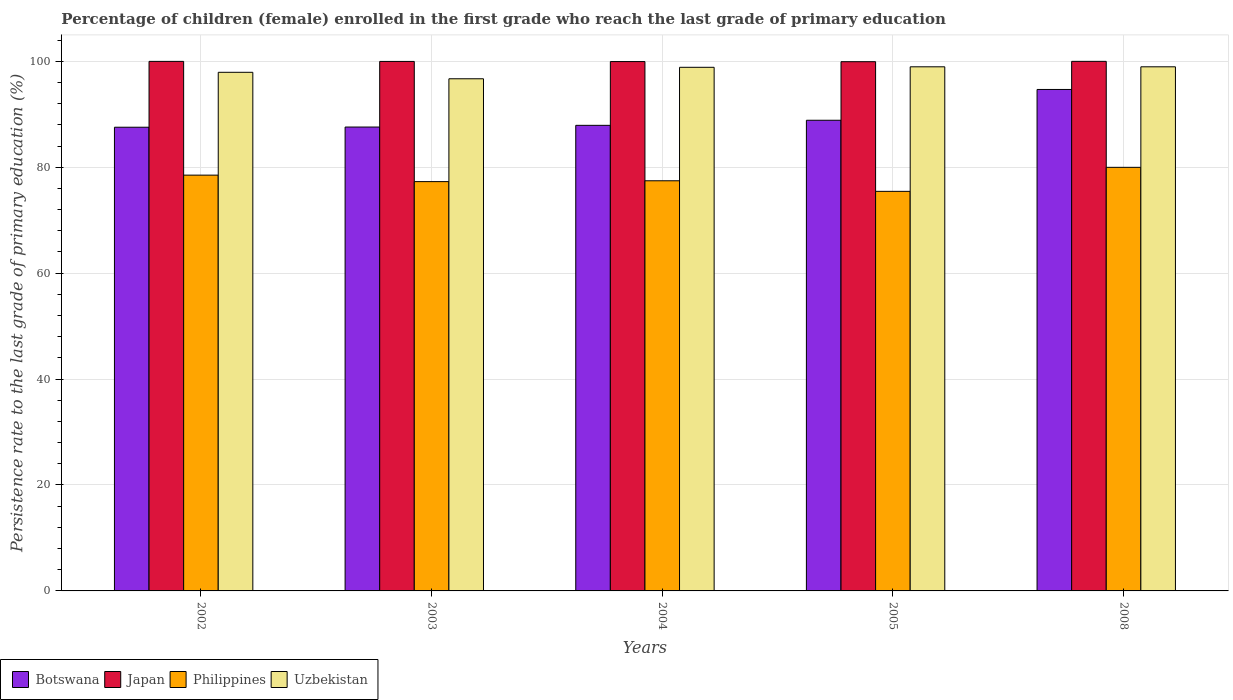Are the number of bars on each tick of the X-axis equal?
Give a very brief answer. Yes. In how many cases, is the number of bars for a given year not equal to the number of legend labels?
Your response must be concise. 0. What is the persistence rate of children in Botswana in 2002?
Provide a short and direct response. 87.55. Across all years, what is the maximum persistence rate of children in Uzbekistan?
Ensure brevity in your answer.  98.96. Across all years, what is the minimum persistence rate of children in Uzbekistan?
Make the answer very short. 96.69. In which year was the persistence rate of children in Philippines minimum?
Give a very brief answer. 2005. What is the total persistence rate of children in Philippines in the graph?
Make the answer very short. 388.63. What is the difference between the persistence rate of children in Botswana in 2002 and that in 2005?
Offer a terse response. -1.32. What is the difference between the persistence rate of children in Uzbekistan in 2008 and the persistence rate of children in Japan in 2003?
Your answer should be compact. -1.01. What is the average persistence rate of children in Japan per year?
Your answer should be compact. 99.96. In the year 2004, what is the difference between the persistence rate of children in Japan and persistence rate of children in Philippines?
Ensure brevity in your answer.  22.51. What is the ratio of the persistence rate of children in Botswana in 2003 to that in 2005?
Your answer should be compact. 0.99. Is the difference between the persistence rate of children in Japan in 2002 and 2003 greater than the difference between the persistence rate of children in Philippines in 2002 and 2003?
Give a very brief answer. No. What is the difference between the highest and the second highest persistence rate of children in Botswana?
Give a very brief answer. 5.81. What is the difference between the highest and the lowest persistence rate of children in Botswana?
Offer a very short reply. 7.13. Is the sum of the persistence rate of children in Philippines in 2002 and 2004 greater than the maximum persistence rate of children in Uzbekistan across all years?
Your response must be concise. Yes. Is it the case that in every year, the sum of the persistence rate of children in Philippines and persistence rate of children in Japan is greater than the sum of persistence rate of children in Botswana and persistence rate of children in Uzbekistan?
Offer a terse response. Yes. What does the 1st bar from the left in 2008 represents?
Keep it short and to the point. Botswana. How many bars are there?
Your answer should be compact. 20. Are all the bars in the graph horizontal?
Ensure brevity in your answer.  No. What is the difference between two consecutive major ticks on the Y-axis?
Give a very brief answer. 20. Where does the legend appear in the graph?
Make the answer very short. Bottom left. What is the title of the graph?
Ensure brevity in your answer.  Percentage of children (female) enrolled in the first grade who reach the last grade of primary education. Does "Philippines" appear as one of the legend labels in the graph?
Your answer should be very brief. Yes. What is the label or title of the X-axis?
Offer a very short reply. Years. What is the label or title of the Y-axis?
Make the answer very short. Persistence rate to the last grade of primary education (%). What is the Persistence rate to the last grade of primary education (%) in Botswana in 2002?
Provide a short and direct response. 87.55. What is the Persistence rate to the last grade of primary education (%) of Japan in 2002?
Give a very brief answer. 99.98. What is the Persistence rate to the last grade of primary education (%) in Philippines in 2002?
Offer a terse response. 78.5. What is the Persistence rate to the last grade of primary education (%) of Uzbekistan in 2002?
Keep it short and to the point. 97.92. What is the Persistence rate to the last grade of primary education (%) of Botswana in 2003?
Provide a succinct answer. 87.58. What is the Persistence rate to the last grade of primary education (%) in Japan in 2003?
Make the answer very short. 99.97. What is the Persistence rate to the last grade of primary education (%) of Philippines in 2003?
Offer a terse response. 77.28. What is the Persistence rate to the last grade of primary education (%) in Uzbekistan in 2003?
Provide a succinct answer. 96.69. What is the Persistence rate to the last grade of primary education (%) of Botswana in 2004?
Provide a succinct answer. 87.9. What is the Persistence rate to the last grade of primary education (%) of Japan in 2004?
Provide a short and direct response. 99.94. What is the Persistence rate to the last grade of primary education (%) of Philippines in 2004?
Offer a very short reply. 77.44. What is the Persistence rate to the last grade of primary education (%) of Uzbekistan in 2004?
Your response must be concise. 98.86. What is the Persistence rate to the last grade of primary education (%) of Botswana in 2005?
Give a very brief answer. 88.86. What is the Persistence rate to the last grade of primary education (%) in Japan in 2005?
Your answer should be very brief. 99.92. What is the Persistence rate to the last grade of primary education (%) of Philippines in 2005?
Provide a short and direct response. 75.44. What is the Persistence rate to the last grade of primary education (%) in Uzbekistan in 2005?
Provide a succinct answer. 98.95. What is the Persistence rate to the last grade of primary education (%) of Botswana in 2008?
Make the answer very short. 94.68. What is the Persistence rate to the last grade of primary education (%) in Japan in 2008?
Your answer should be very brief. 99.98. What is the Persistence rate to the last grade of primary education (%) of Philippines in 2008?
Your response must be concise. 79.98. What is the Persistence rate to the last grade of primary education (%) of Uzbekistan in 2008?
Your answer should be compact. 98.96. Across all years, what is the maximum Persistence rate to the last grade of primary education (%) of Botswana?
Offer a terse response. 94.68. Across all years, what is the maximum Persistence rate to the last grade of primary education (%) of Japan?
Offer a terse response. 99.98. Across all years, what is the maximum Persistence rate to the last grade of primary education (%) in Philippines?
Provide a short and direct response. 79.98. Across all years, what is the maximum Persistence rate to the last grade of primary education (%) of Uzbekistan?
Give a very brief answer. 98.96. Across all years, what is the minimum Persistence rate to the last grade of primary education (%) in Botswana?
Provide a succinct answer. 87.55. Across all years, what is the minimum Persistence rate to the last grade of primary education (%) of Japan?
Provide a succinct answer. 99.92. Across all years, what is the minimum Persistence rate to the last grade of primary education (%) in Philippines?
Make the answer very short. 75.44. Across all years, what is the minimum Persistence rate to the last grade of primary education (%) in Uzbekistan?
Offer a terse response. 96.69. What is the total Persistence rate to the last grade of primary education (%) of Botswana in the graph?
Your response must be concise. 446.57. What is the total Persistence rate to the last grade of primary education (%) in Japan in the graph?
Your answer should be compact. 499.8. What is the total Persistence rate to the last grade of primary education (%) of Philippines in the graph?
Your answer should be compact. 388.63. What is the total Persistence rate to the last grade of primary education (%) of Uzbekistan in the graph?
Make the answer very short. 491.38. What is the difference between the Persistence rate to the last grade of primary education (%) of Botswana in 2002 and that in 2003?
Provide a succinct answer. -0.03. What is the difference between the Persistence rate to the last grade of primary education (%) of Japan in 2002 and that in 2003?
Provide a succinct answer. 0.01. What is the difference between the Persistence rate to the last grade of primary education (%) in Philippines in 2002 and that in 2003?
Provide a short and direct response. 1.23. What is the difference between the Persistence rate to the last grade of primary education (%) of Uzbekistan in 2002 and that in 2003?
Your answer should be very brief. 1.22. What is the difference between the Persistence rate to the last grade of primary education (%) in Botswana in 2002 and that in 2004?
Your answer should be compact. -0.36. What is the difference between the Persistence rate to the last grade of primary education (%) of Japan in 2002 and that in 2004?
Your answer should be very brief. 0.04. What is the difference between the Persistence rate to the last grade of primary education (%) in Philippines in 2002 and that in 2004?
Your answer should be compact. 1.07. What is the difference between the Persistence rate to the last grade of primary education (%) of Uzbekistan in 2002 and that in 2004?
Keep it short and to the point. -0.94. What is the difference between the Persistence rate to the last grade of primary education (%) of Botswana in 2002 and that in 2005?
Your answer should be very brief. -1.32. What is the difference between the Persistence rate to the last grade of primary education (%) of Japan in 2002 and that in 2005?
Your answer should be very brief. 0.06. What is the difference between the Persistence rate to the last grade of primary education (%) in Philippines in 2002 and that in 2005?
Your response must be concise. 3.06. What is the difference between the Persistence rate to the last grade of primary education (%) in Uzbekistan in 2002 and that in 2005?
Give a very brief answer. -1.04. What is the difference between the Persistence rate to the last grade of primary education (%) in Botswana in 2002 and that in 2008?
Your answer should be very brief. -7.13. What is the difference between the Persistence rate to the last grade of primary education (%) of Japan in 2002 and that in 2008?
Your response must be concise. -0. What is the difference between the Persistence rate to the last grade of primary education (%) of Philippines in 2002 and that in 2008?
Give a very brief answer. -1.47. What is the difference between the Persistence rate to the last grade of primary education (%) in Uzbekistan in 2002 and that in 2008?
Offer a very short reply. -1.04. What is the difference between the Persistence rate to the last grade of primary education (%) in Botswana in 2003 and that in 2004?
Give a very brief answer. -0.32. What is the difference between the Persistence rate to the last grade of primary education (%) of Japan in 2003 and that in 2004?
Ensure brevity in your answer.  0.03. What is the difference between the Persistence rate to the last grade of primary education (%) in Philippines in 2003 and that in 2004?
Provide a succinct answer. -0.16. What is the difference between the Persistence rate to the last grade of primary education (%) in Uzbekistan in 2003 and that in 2004?
Your answer should be very brief. -2.17. What is the difference between the Persistence rate to the last grade of primary education (%) in Botswana in 2003 and that in 2005?
Give a very brief answer. -1.28. What is the difference between the Persistence rate to the last grade of primary education (%) of Japan in 2003 and that in 2005?
Ensure brevity in your answer.  0.05. What is the difference between the Persistence rate to the last grade of primary education (%) of Philippines in 2003 and that in 2005?
Provide a succinct answer. 1.84. What is the difference between the Persistence rate to the last grade of primary education (%) of Uzbekistan in 2003 and that in 2005?
Provide a succinct answer. -2.26. What is the difference between the Persistence rate to the last grade of primary education (%) of Botswana in 2003 and that in 2008?
Offer a terse response. -7.1. What is the difference between the Persistence rate to the last grade of primary education (%) of Japan in 2003 and that in 2008?
Ensure brevity in your answer.  -0.01. What is the difference between the Persistence rate to the last grade of primary education (%) in Philippines in 2003 and that in 2008?
Provide a short and direct response. -2.7. What is the difference between the Persistence rate to the last grade of primary education (%) in Uzbekistan in 2003 and that in 2008?
Your answer should be very brief. -2.26. What is the difference between the Persistence rate to the last grade of primary education (%) of Botswana in 2004 and that in 2005?
Your answer should be very brief. -0.96. What is the difference between the Persistence rate to the last grade of primary education (%) in Japan in 2004 and that in 2005?
Make the answer very short. 0.02. What is the difference between the Persistence rate to the last grade of primary education (%) in Philippines in 2004 and that in 2005?
Your response must be concise. 2. What is the difference between the Persistence rate to the last grade of primary education (%) of Uzbekistan in 2004 and that in 2005?
Provide a short and direct response. -0.09. What is the difference between the Persistence rate to the last grade of primary education (%) of Botswana in 2004 and that in 2008?
Your answer should be very brief. -6.77. What is the difference between the Persistence rate to the last grade of primary education (%) of Japan in 2004 and that in 2008?
Keep it short and to the point. -0.04. What is the difference between the Persistence rate to the last grade of primary education (%) of Philippines in 2004 and that in 2008?
Offer a terse response. -2.54. What is the difference between the Persistence rate to the last grade of primary education (%) in Uzbekistan in 2004 and that in 2008?
Give a very brief answer. -0.1. What is the difference between the Persistence rate to the last grade of primary education (%) in Botswana in 2005 and that in 2008?
Make the answer very short. -5.81. What is the difference between the Persistence rate to the last grade of primary education (%) in Japan in 2005 and that in 2008?
Your answer should be very brief. -0.06. What is the difference between the Persistence rate to the last grade of primary education (%) of Philippines in 2005 and that in 2008?
Offer a terse response. -4.54. What is the difference between the Persistence rate to the last grade of primary education (%) in Uzbekistan in 2005 and that in 2008?
Provide a short and direct response. -0. What is the difference between the Persistence rate to the last grade of primary education (%) in Botswana in 2002 and the Persistence rate to the last grade of primary education (%) in Japan in 2003?
Provide a succinct answer. -12.42. What is the difference between the Persistence rate to the last grade of primary education (%) of Botswana in 2002 and the Persistence rate to the last grade of primary education (%) of Philippines in 2003?
Give a very brief answer. 10.27. What is the difference between the Persistence rate to the last grade of primary education (%) in Botswana in 2002 and the Persistence rate to the last grade of primary education (%) in Uzbekistan in 2003?
Ensure brevity in your answer.  -9.15. What is the difference between the Persistence rate to the last grade of primary education (%) of Japan in 2002 and the Persistence rate to the last grade of primary education (%) of Philippines in 2003?
Ensure brevity in your answer.  22.7. What is the difference between the Persistence rate to the last grade of primary education (%) in Japan in 2002 and the Persistence rate to the last grade of primary education (%) in Uzbekistan in 2003?
Your response must be concise. 3.29. What is the difference between the Persistence rate to the last grade of primary education (%) of Philippines in 2002 and the Persistence rate to the last grade of primary education (%) of Uzbekistan in 2003?
Offer a terse response. -18.19. What is the difference between the Persistence rate to the last grade of primary education (%) in Botswana in 2002 and the Persistence rate to the last grade of primary education (%) in Japan in 2004?
Ensure brevity in your answer.  -12.39. What is the difference between the Persistence rate to the last grade of primary education (%) of Botswana in 2002 and the Persistence rate to the last grade of primary education (%) of Philippines in 2004?
Provide a short and direct response. 10.11. What is the difference between the Persistence rate to the last grade of primary education (%) of Botswana in 2002 and the Persistence rate to the last grade of primary education (%) of Uzbekistan in 2004?
Your response must be concise. -11.31. What is the difference between the Persistence rate to the last grade of primary education (%) in Japan in 2002 and the Persistence rate to the last grade of primary education (%) in Philippines in 2004?
Your answer should be compact. 22.54. What is the difference between the Persistence rate to the last grade of primary education (%) in Japan in 2002 and the Persistence rate to the last grade of primary education (%) in Uzbekistan in 2004?
Provide a succinct answer. 1.12. What is the difference between the Persistence rate to the last grade of primary education (%) of Philippines in 2002 and the Persistence rate to the last grade of primary education (%) of Uzbekistan in 2004?
Offer a very short reply. -20.36. What is the difference between the Persistence rate to the last grade of primary education (%) in Botswana in 2002 and the Persistence rate to the last grade of primary education (%) in Japan in 2005?
Give a very brief answer. -12.37. What is the difference between the Persistence rate to the last grade of primary education (%) in Botswana in 2002 and the Persistence rate to the last grade of primary education (%) in Philippines in 2005?
Ensure brevity in your answer.  12.11. What is the difference between the Persistence rate to the last grade of primary education (%) in Botswana in 2002 and the Persistence rate to the last grade of primary education (%) in Uzbekistan in 2005?
Your response must be concise. -11.41. What is the difference between the Persistence rate to the last grade of primary education (%) of Japan in 2002 and the Persistence rate to the last grade of primary education (%) of Philippines in 2005?
Your response must be concise. 24.54. What is the difference between the Persistence rate to the last grade of primary education (%) of Japan in 2002 and the Persistence rate to the last grade of primary education (%) of Uzbekistan in 2005?
Provide a succinct answer. 1.03. What is the difference between the Persistence rate to the last grade of primary education (%) of Philippines in 2002 and the Persistence rate to the last grade of primary education (%) of Uzbekistan in 2005?
Keep it short and to the point. -20.45. What is the difference between the Persistence rate to the last grade of primary education (%) of Botswana in 2002 and the Persistence rate to the last grade of primary education (%) of Japan in 2008?
Make the answer very short. -12.44. What is the difference between the Persistence rate to the last grade of primary education (%) in Botswana in 2002 and the Persistence rate to the last grade of primary education (%) in Philippines in 2008?
Give a very brief answer. 7.57. What is the difference between the Persistence rate to the last grade of primary education (%) in Botswana in 2002 and the Persistence rate to the last grade of primary education (%) in Uzbekistan in 2008?
Provide a short and direct response. -11.41. What is the difference between the Persistence rate to the last grade of primary education (%) in Japan in 2002 and the Persistence rate to the last grade of primary education (%) in Philippines in 2008?
Your answer should be very brief. 20. What is the difference between the Persistence rate to the last grade of primary education (%) of Japan in 2002 and the Persistence rate to the last grade of primary education (%) of Uzbekistan in 2008?
Offer a terse response. 1.02. What is the difference between the Persistence rate to the last grade of primary education (%) of Philippines in 2002 and the Persistence rate to the last grade of primary education (%) of Uzbekistan in 2008?
Provide a succinct answer. -20.45. What is the difference between the Persistence rate to the last grade of primary education (%) in Botswana in 2003 and the Persistence rate to the last grade of primary education (%) in Japan in 2004?
Your answer should be very brief. -12.36. What is the difference between the Persistence rate to the last grade of primary education (%) of Botswana in 2003 and the Persistence rate to the last grade of primary education (%) of Philippines in 2004?
Make the answer very short. 10.15. What is the difference between the Persistence rate to the last grade of primary education (%) in Botswana in 2003 and the Persistence rate to the last grade of primary education (%) in Uzbekistan in 2004?
Your answer should be compact. -11.28. What is the difference between the Persistence rate to the last grade of primary education (%) in Japan in 2003 and the Persistence rate to the last grade of primary education (%) in Philippines in 2004?
Provide a succinct answer. 22.53. What is the difference between the Persistence rate to the last grade of primary education (%) in Japan in 2003 and the Persistence rate to the last grade of primary education (%) in Uzbekistan in 2004?
Make the answer very short. 1.11. What is the difference between the Persistence rate to the last grade of primary education (%) in Philippines in 2003 and the Persistence rate to the last grade of primary education (%) in Uzbekistan in 2004?
Offer a very short reply. -21.58. What is the difference between the Persistence rate to the last grade of primary education (%) of Botswana in 2003 and the Persistence rate to the last grade of primary education (%) of Japan in 2005?
Your answer should be very brief. -12.34. What is the difference between the Persistence rate to the last grade of primary education (%) of Botswana in 2003 and the Persistence rate to the last grade of primary education (%) of Philippines in 2005?
Your answer should be compact. 12.14. What is the difference between the Persistence rate to the last grade of primary education (%) in Botswana in 2003 and the Persistence rate to the last grade of primary education (%) in Uzbekistan in 2005?
Your response must be concise. -11.37. What is the difference between the Persistence rate to the last grade of primary education (%) of Japan in 2003 and the Persistence rate to the last grade of primary education (%) of Philippines in 2005?
Keep it short and to the point. 24.53. What is the difference between the Persistence rate to the last grade of primary education (%) in Japan in 2003 and the Persistence rate to the last grade of primary education (%) in Uzbekistan in 2005?
Provide a short and direct response. 1.02. What is the difference between the Persistence rate to the last grade of primary education (%) in Philippines in 2003 and the Persistence rate to the last grade of primary education (%) in Uzbekistan in 2005?
Offer a terse response. -21.68. What is the difference between the Persistence rate to the last grade of primary education (%) of Botswana in 2003 and the Persistence rate to the last grade of primary education (%) of Japan in 2008?
Keep it short and to the point. -12.4. What is the difference between the Persistence rate to the last grade of primary education (%) in Botswana in 2003 and the Persistence rate to the last grade of primary education (%) in Philippines in 2008?
Keep it short and to the point. 7.61. What is the difference between the Persistence rate to the last grade of primary education (%) of Botswana in 2003 and the Persistence rate to the last grade of primary education (%) of Uzbekistan in 2008?
Your answer should be compact. -11.37. What is the difference between the Persistence rate to the last grade of primary education (%) in Japan in 2003 and the Persistence rate to the last grade of primary education (%) in Philippines in 2008?
Keep it short and to the point. 19.99. What is the difference between the Persistence rate to the last grade of primary education (%) of Japan in 2003 and the Persistence rate to the last grade of primary education (%) of Uzbekistan in 2008?
Provide a succinct answer. 1.01. What is the difference between the Persistence rate to the last grade of primary education (%) in Philippines in 2003 and the Persistence rate to the last grade of primary education (%) in Uzbekistan in 2008?
Your response must be concise. -21.68. What is the difference between the Persistence rate to the last grade of primary education (%) of Botswana in 2004 and the Persistence rate to the last grade of primary education (%) of Japan in 2005?
Keep it short and to the point. -12.02. What is the difference between the Persistence rate to the last grade of primary education (%) in Botswana in 2004 and the Persistence rate to the last grade of primary education (%) in Philippines in 2005?
Your answer should be very brief. 12.46. What is the difference between the Persistence rate to the last grade of primary education (%) in Botswana in 2004 and the Persistence rate to the last grade of primary education (%) in Uzbekistan in 2005?
Your answer should be compact. -11.05. What is the difference between the Persistence rate to the last grade of primary education (%) of Japan in 2004 and the Persistence rate to the last grade of primary education (%) of Philippines in 2005?
Ensure brevity in your answer.  24.5. What is the difference between the Persistence rate to the last grade of primary education (%) of Philippines in 2004 and the Persistence rate to the last grade of primary education (%) of Uzbekistan in 2005?
Your answer should be compact. -21.52. What is the difference between the Persistence rate to the last grade of primary education (%) of Botswana in 2004 and the Persistence rate to the last grade of primary education (%) of Japan in 2008?
Your answer should be compact. -12.08. What is the difference between the Persistence rate to the last grade of primary education (%) of Botswana in 2004 and the Persistence rate to the last grade of primary education (%) of Philippines in 2008?
Your response must be concise. 7.93. What is the difference between the Persistence rate to the last grade of primary education (%) in Botswana in 2004 and the Persistence rate to the last grade of primary education (%) in Uzbekistan in 2008?
Make the answer very short. -11.05. What is the difference between the Persistence rate to the last grade of primary education (%) in Japan in 2004 and the Persistence rate to the last grade of primary education (%) in Philippines in 2008?
Offer a very short reply. 19.97. What is the difference between the Persistence rate to the last grade of primary education (%) of Japan in 2004 and the Persistence rate to the last grade of primary education (%) of Uzbekistan in 2008?
Give a very brief answer. 0.99. What is the difference between the Persistence rate to the last grade of primary education (%) of Philippines in 2004 and the Persistence rate to the last grade of primary education (%) of Uzbekistan in 2008?
Your answer should be compact. -21.52. What is the difference between the Persistence rate to the last grade of primary education (%) in Botswana in 2005 and the Persistence rate to the last grade of primary education (%) in Japan in 2008?
Make the answer very short. -11.12. What is the difference between the Persistence rate to the last grade of primary education (%) in Botswana in 2005 and the Persistence rate to the last grade of primary education (%) in Philippines in 2008?
Your response must be concise. 8.89. What is the difference between the Persistence rate to the last grade of primary education (%) in Botswana in 2005 and the Persistence rate to the last grade of primary education (%) in Uzbekistan in 2008?
Keep it short and to the point. -10.09. What is the difference between the Persistence rate to the last grade of primary education (%) in Japan in 2005 and the Persistence rate to the last grade of primary education (%) in Philippines in 2008?
Keep it short and to the point. 19.94. What is the difference between the Persistence rate to the last grade of primary education (%) in Japan in 2005 and the Persistence rate to the last grade of primary education (%) in Uzbekistan in 2008?
Ensure brevity in your answer.  0.96. What is the difference between the Persistence rate to the last grade of primary education (%) in Philippines in 2005 and the Persistence rate to the last grade of primary education (%) in Uzbekistan in 2008?
Give a very brief answer. -23.52. What is the average Persistence rate to the last grade of primary education (%) in Botswana per year?
Ensure brevity in your answer.  89.31. What is the average Persistence rate to the last grade of primary education (%) in Japan per year?
Give a very brief answer. 99.96. What is the average Persistence rate to the last grade of primary education (%) of Philippines per year?
Offer a very short reply. 77.73. What is the average Persistence rate to the last grade of primary education (%) of Uzbekistan per year?
Provide a succinct answer. 98.28. In the year 2002, what is the difference between the Persistence rate to the last grade of primary education (%) of Botswana and Persistence rate to the last grade of primary education (%) of Japan?
Give a very brief answer. -12.43. In the year 2002, what is the difference between the Persistence rate to the last grade of primary education (%) of Botswana and Persistence rate to the last grade of primary education (%) of Philippines?
Your response must be concise. 9.05. In the year 2002, what is the difference between the Persistence rate to the last grade of primary education (%) of Botswana and Persistence rate to the last grade of primary education (%) of Uzbekistan?
Provide a succinct answer. -10.37. In the year 2002, what is the difference between the Persistence rate to the last grade of primary education (%) of Japan and Persistence rate to the last grade of primary education (%) of Philippines?
Your response must be concise. 21.48. In the year 2002, what is the difference between the Persistence rate to the last grade of primary education (%) in Japan and Persistence rate to the last grade of primary education (%) in Uzbekistan?
Provide a succinct answer. 2.06. In the year 2002, what is the difference between the Persistence rate to the last grade of primary education (%) of Philippines and Persistence rate to the last grade of primary education (%) of Uzbekistan?
Keep it short and to the point. -19.41. In the year 2003, what is the difference between the Persistence rate to the last grade of primary education (%) of Botswana and Persistence rate to the last grade of primary education (%) of Japan?
Your answer should be very brief. -12.39. In the year 2003, what is the difference between the Persistence rate to the last grade of primary education (%) in Botswana and Persistence rate to the last grade of primary education (%) in Philippines?
Make the answer very short. 10.3. In the year 2003, what is the difference between the Persistence rate to the last grade of primary education (%) of Botswana and Persistence rate to the last grade of primary education (%) of Uzbekistan?
Give a very brief answer. -9.11. In the year 2003, what is the difference between the Persistence rate to the last grade of primary education (%) of Japan and Persistence rate to the last grade of primary education (%) of Philippines?
Your answer should be very brief. 22.69. In the year 2003, what is the difference between the Persistence rate to the last grade of primary education (%) of Japan and Persistence rate to the last grade of primary education (%) of Uzbekistan?
Offer a terse response. 3.27. In the year 2003, what is the difference between the Persistence rate to the last grade of primary education (%) of Philippines and Persistence rate to the last grade of primary education (%) of Uzbekistan?
Offer a terse response. -19.42. In the year 2004, what is the difference between the Persistence rate to the last grade of primary education (%) of Botswana and Persistence rate to the last grade of primary education (%) of Japan?
Provide a succinct answer. -12.04. In the year 2004, what is the difference between the Persistence rate to the last grade of primary education (%) of Botswana and Persistence rate to the last grade of primary education (%) of Philippines?
Your response must be concise. 10.47. In the year 2004, what is the difference between the Persistence rate to the last grade of primary education (%) in Botswana and Persistence rate to the last grade of primary education (%) in Uzbekistan?
Your answer should be compact. -10.96. In the year 2004, what is the difference between the Persistence rate to the last grade of primary education (%) in Japan and Persistence rate to the last grade of primary education (%) in Philippines?
Offer a terse response. 22.51. In the year 2004, what is the difference between the Persistence rate to the last grade of primary education (%) of Japan and Persistence rate to the last grade of primary education (%) of Uzbekistan?
Your answer should be very brief. 1.08. In the year 2004, what is the difference between the Persistence rate to the last grade of primary education (%) of Philippines and Persistence rate to the last grade of primary education (%) of Uzbekistan?
Ensure brevity in your answer.  -21.42. In the year 2005, what is the difference between the Persistence rate to the last grade of primary education (%) in Botswana and Persistence rate to the last grade of primary education (%) in Japan?
Offer a very short reply. -11.06. In the year 2005, what is the difference between the Persistence rate to the last grade of primary education (%) in Botswana and Persistence rate to the last grade of primary education (%) in Philippines?
Your answer should be very brief. 13.42. In the year 2005, what is the difference between the Persistence rate to the last grade of primary education (%) in Botswana and Persistence rate to the last grade of primary education (%) in Uzbekistan?
Provide a short and direct response. -10.09. In the year 2005, what is the difference between the Persistence rate to the last grade of primary education (%) of Japan and Persistence rate to the last grade of primary education (%) of Philippines?
Keep it short and to the point. 24.48. In the year 2005, what is the difference between the Persistence rate to the last grade of primary education (%) in Japan and Persistence rate to the last grade of primary education (%) in Uzbekistan?
Provide a succinct answer. 0.97. In the year 2005, what is the difference between the Persistence rate to the last grade of primary education (%) of Philippines and Persistence rate to the last grade of primary education (%) of Uzbekistan?
Make the answer very short. -23.51. In the year 2008, what is the difference between the Persistence rate to the last grade of primary education (%) of Botswana and Persistence rate to the last grade of primary education (%) of Japan?
Provide a short and direct response. -5.31. In the year 2008, what is the difference between the Persistence rate to the last grade of primary education (%) of Botswana and Persistence rate to the last grade of primary education (%) of Philippines?
Offer a terse response. 14.7. In the year 2008, what is the difference between the Persistence rate to the last grade of primary education (%) in Botswana and Persistence rate to the last grade of primary education (%) in Uzbekistan?
Offer a very short reply. -4.28. In the year 2008, what is the difference between the Persistence rate to the last grade of primary education (%) in Japan and Persistence rate to the last grade of primary education (%) in Philippines?
Provide a succinct answer. 20.01. In the year 2008, what is the difference between the Persistence rate to the last grade of primary education (%) of Japan and Persistence rate to the last grade of primary education (%) of Uzbekistan?
Keep it short and to the point. 1.03. In the year 2008, what is the difference between the Persistence rate to the last grade of primary education (%) in Philippines and Persistence rate to the last grade of primary education (%) in Uzbekistan?
Ensure brevity in your answer.  -18.98. What is the ratio of the Persistence rate to the last grade of primary education (%) of Japan in 2002 to that in 2003?
Offer a very short reply. 1. What is the ratio of the Persistence rate to the last grade of primary education (%) in Philippines in 2002 to that in 2003?
Your answer should be very brief. 1.02. What is the ratio of the Persistence rate to the last grade of primary education (%) of Uzbekistan in 2002 to that in 2003?
Offer a terse response. 1.01. What is the ratio of the Persistence rate to the last grade of primary education (%) in Botswana in 2002 to that in 2004?
Keep it short and to the point. 1. What is the ratio of the Persistence rate to the last grade of primary education (%) in Philippines in 2002 to that in 2004?
Ensure brevity in your answer.  1.01. What is the ratio of the Persistence rate to the last grade of primary education (%) of Botswana in 2002 to that in 2005?
Your answer should be very brief. 0.99. What is the ratio of the Persistence rate to the last grade of primary education (%) in Philippines in 2002 to that in 2005?
Provide a short and direct response. 1.04. What is the ratio of the Persistence rate to the last grade of primary education (%) of Botswana in 2002 to that in 2008?
Keep it short and to the point. 0.92. What is the ratio of the Persistence rate to the last grade of primary education (%) in Philippines in 2002 to that in 2008?
Your answer should be very brief. 0.98. What is the ratio of the Persistence rate to the last grade of primary education (%) in Japan in 2003 to that in 2004?
Offer a very short reply. 1. What is the ratio of the Persistence rate to the last grade of primary education (%) of Philippines in 2003 to that in 2004?
Your response must be concise. 1. What is the ratio of the Persistence rate to the last grade of primary education (%) of Uzbekistan in 2003 to that in 2004?
Your answer should be very brief. 0.98. What is the ratio of the Persistence rate to the last grade of primary education (%) in Botswana in 2003 to that in 2005?
Your response must be concise. 0.99. What is the ratio of the Persistence rate to the last grade of primary education (%) in Philippines in 2003 to that in 2005?
Your answer should be very brief. 1.02. What is the ratio of the Persistence rate to the last grade of primary education (%) of Uzbekistan in 2003 to that in 2005?
Provide a succinct answer. 0.98. What is the ratio of the Persistence rate to the last grade of primary education (%) of Botswana in 2003 to that in 2008?
Offer a very short reply. 0.93. What is the ratio of the Persistence rate to the last grade of primary education (%) in Philippines in 2003 to that in 2008?
Your answer should be very brief. 0.97. What is the ratio of the Persistence rate to the last grade of primary education (%) of Uzbekistan in 2003 to that in 2008?
Give a very brief answer. 0.98. What is the ratio of the Persistence rate to the last grade of primary education (%) in Botswana in 2004 to that in 2005?
Ensure brevity in your answer.  0.99. What is the ratio of the Persistence rate to the last grade of primary education (%) in Japan in 2004 to that in 2005?
Offer a very short reply. 1. What is the ratio of the Persistence rate to the last grade of primary education (%) of Philippines in 2004 to that in 2005?
Ensure brevity in your answer.  1.03. What is the ratio of the Persistence rate to the last grade of primary education (%) of Botswana in 2004 to that in 2008?
Provide a short and direct response. 0.93. What is the ratio of the Persistence rate to the last grade of primary education (%) in Philippines in 2004 to that in 2008?
Provide a succinct answer. 0.97. What is the ratio of the Persistence rate to the last grade of primary education (%) of Botswana in 2005 to that in 2008?
Make the answer very short. 0.94. What is the ratio of the Persistence rate to the last grade of primary education (%) of Philippines in 2005 to that in 2008?
Your answer should be very brief. 0.94. What is the ratio of the Persistence rate to the last grade of primary education (%) in Uzbekistan in 2005 to that in 2008?
Your answer should be very brief. 1. What is the difference between the highest and the second highest Persistence rate to the last grade of primary education (%) of Botswana?
Your answer should be very brief. 5.81. What is the difference between the highest and the second highest Persistence rate to the last grade of primary education (%) of Japan?
Give a very brief answer. 0. What is the difference between the highest and the second highest Persistence rate to the last grade of primary education (%) of Philippines?
Keep it short and to the point. 1.47. What is the difference between the highest and the second highest Persistence rate to the last grade of primary education (%) of Uzbekistan?
Your answer should be very brief. 0. What is the difference between the highest and the lowest Persistence rate to the last grade of primary education (%) in Botswana?
Keep it short and to the point. 7.13. What is the difference between the highest and the lowest Persistence rate to the last grade of primary education (%) in Japan?
Ensure brevity in your answer.  0.06. What is the difference between the highest and the lowest Persistence rate to the last grade of primary education (%) in Philippines?
Make the answer very short. 4.54. What is the difference between the highest and the lowest Persistence rate to the last grade of primary education (%) of Uzbekistan?
Provide a short and direct response. 2.26. 